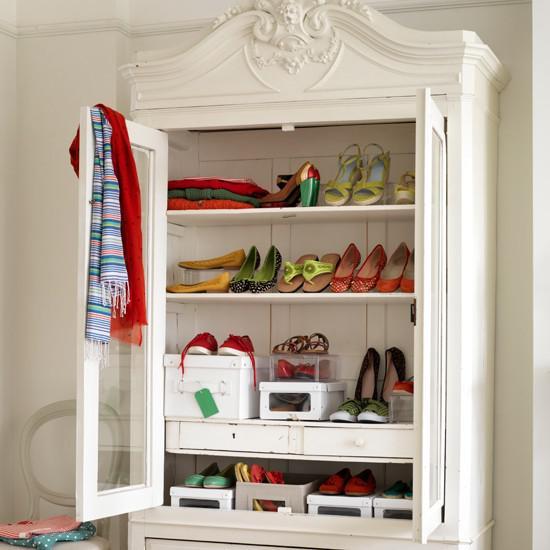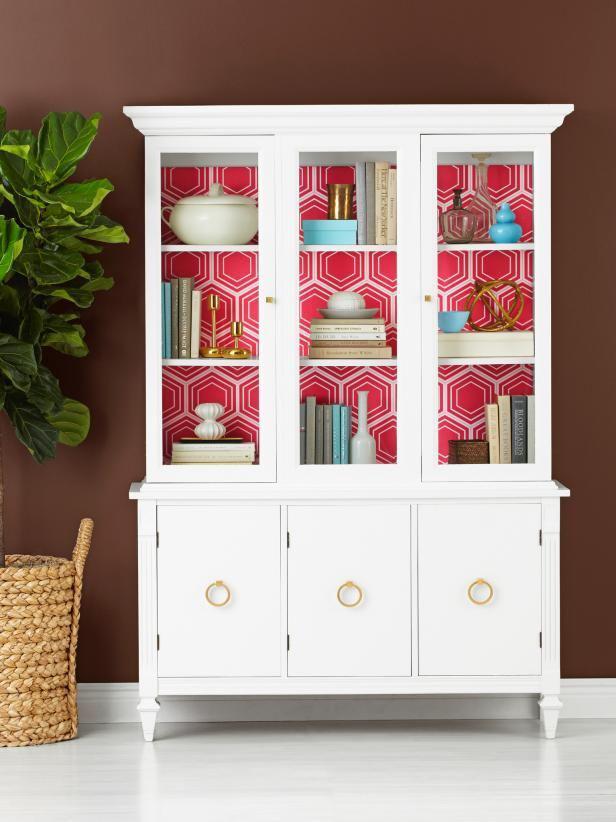The first image is the image on the left, the second image is the image on the right. Given the left and right images, does the statement "The cabinet in the image on the right is charcoal grey, while the one on the left is white." hold true? Answer yes or no. No. The first image is the image on the left, the second image is the image on the right. Analyze the images presented: Is the assertion "One white hutch has a straight top and three shelves in the upper section, and a gray hutch has an upper center glass door that is wider than the two side glass sections." valid? Answer yes or no. No. 